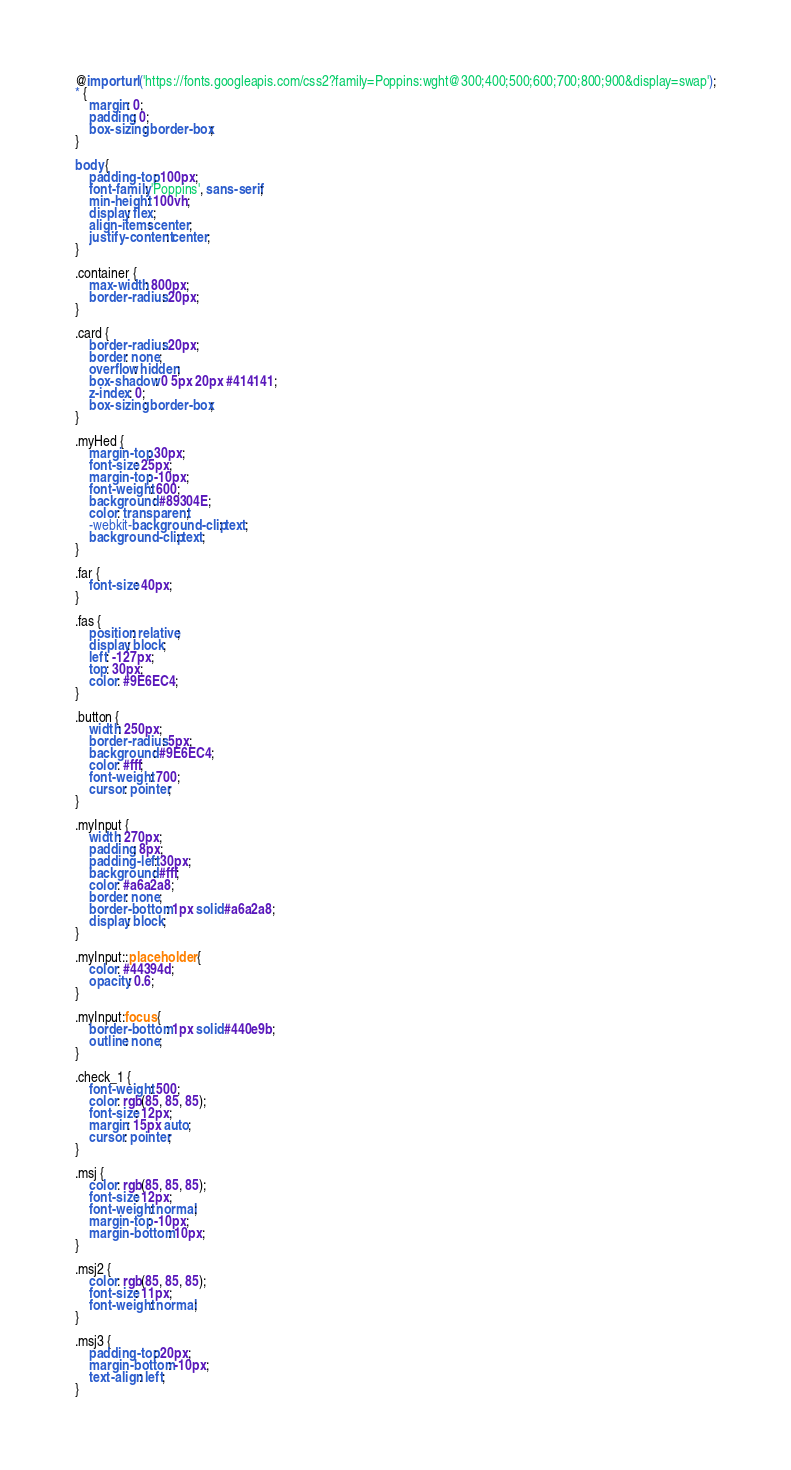<code> <loc_0><loc_0><loc_500><loc_500><_CSS_>@import url('https://fonts.googleapis.com/css2?family=Poppins:wght@300;400;500;600;700;800;900&display=swap');
* {
    margin: 0;
    padding: 0;
    box-sizing: border-box;
}

body {
    padding-top: 100px;
    font-family: 'Poppins', sans-serif;
    min-height: 100vh;
    display: flex;
    align-items: center;
    justify-content: center;
}

.container {
    max-width: 800px;
    border-radius: 20px;
}

.card {
    border-radius: 20px;
    border: none;
    overflow: hidden;
    box-shadow: 0 5px 20px #414141;
    z-index: 0;
    box-sizing: border-box;
}

.myHed {
    margin-top: 30px;
    font-size: 25px;
    margin-top: -10px;
    font-weight: 600;
    background: #89304E;
    color: transparent;
    -webkit-background-clip: text;
    background-clip: text;
}

.far {
    font-size: 40px;
}

.fas {
    position: relative;
    display: block;
    left: -127px;
    top: 30px;
    color: #9E6EC4;
}

.button {
    width: 250px;
    border-radius: 5px;
    background: #9E6EC4;
    color: #fff;
    font-weight: 700;
    cursor: pointer;
}

.myInput {
    width: 270px;
    padding: 8px;
    padding-left: 30px;
    background: #fff;
    color: #a6a2a8;
    border: none;
    border-bottom: 1px solid #a6a2a8;
    display: block;
}

.myInput::placeholder {
    color: #44394d;
    opacity: 0.6;
}

.myInput:focus {
    border-bottom: 1px solid #440e9b;
    outline: none;
}

.check_1 {
    font-weight: 500;
    color: rgb(85, 85, 85);
    font-size: 12px;
    margin: 15px auto;
    cursor: pointer;
}

.msj {
    color: rgb(85, 85, 85);
    font-size: 12px;
    font-weight: normal;
    margin-top: -10px;
    margin-bottom: 10px;
}

.msj2 {
    color: rgb(85, 85, 85);
    font-size: 11px;
    font-weight: normal;
}

.msj3 {
    padding-top: 20px;
    margin-bottom: -10px;
    text-align: left;
}
</code> 